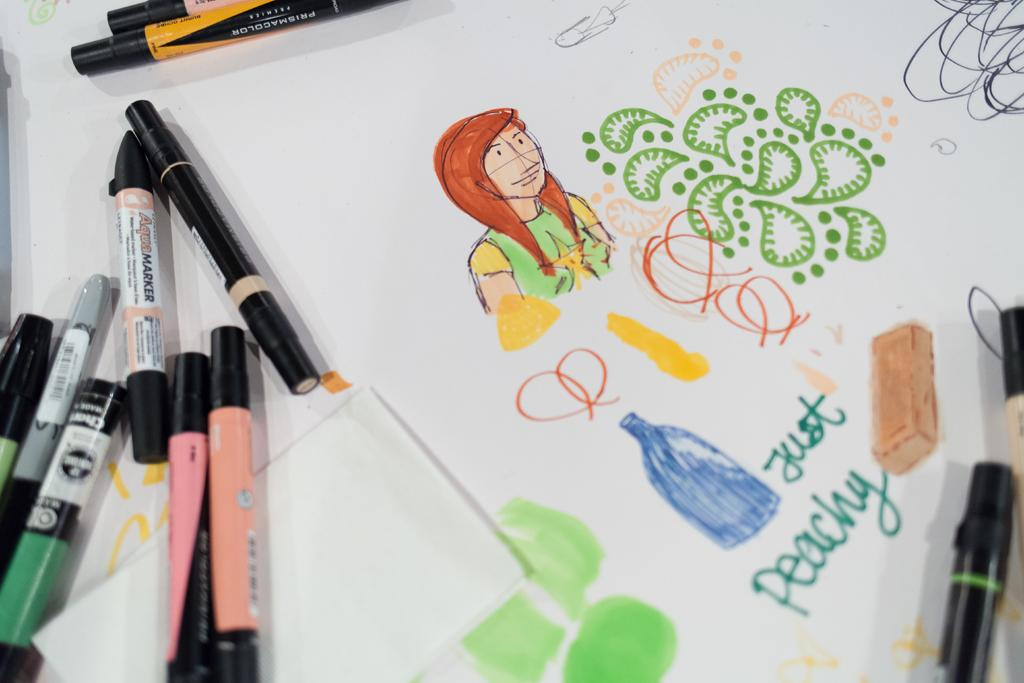What is depicted on the paper in the image? There are diagrams on the paper. What objects are also present on the paper? There are pens on the paper. What type of laborer is shown working on the diagrams in the image? There are no laborers present in the image; it only shows diagrams and pens on the paper. What route is the person taking to reach the diagrams in the image? There is no person present in the image, and therefore no route can be determined. 